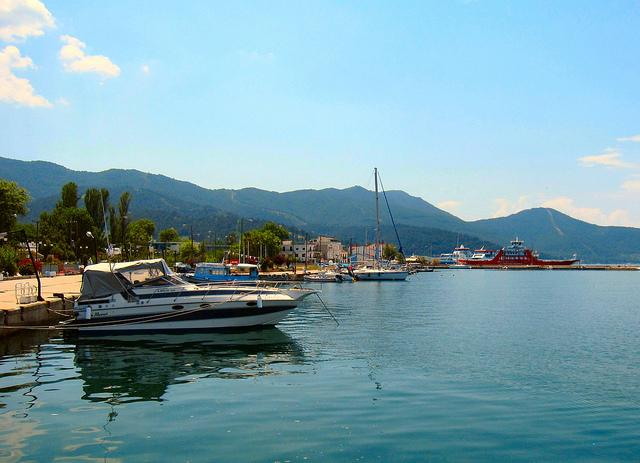What can usually be found in this setting? Please explain your reasoning. fish. These types of animals live in the sea. 